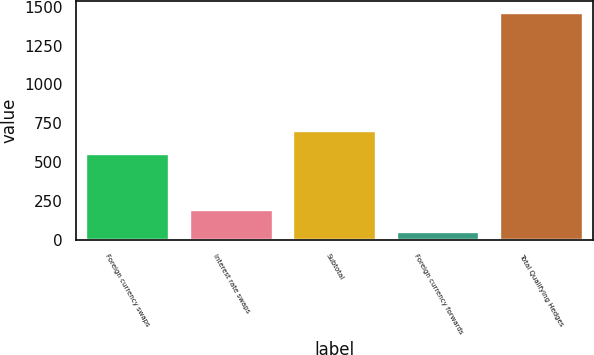<chart> <loc_0><loc_0><loc_500><loc_500><bar_chart><fcel>Foreign currency swaps<fcel>Interest rate swaps<fcel>Subtotal<fcel>Foreign currency forwards<fcel>Total Qualifying Hedges<nl><fcel>550<fcel>191.3<fcel>703<fcel>50<fcel>1463<nl></chart> 